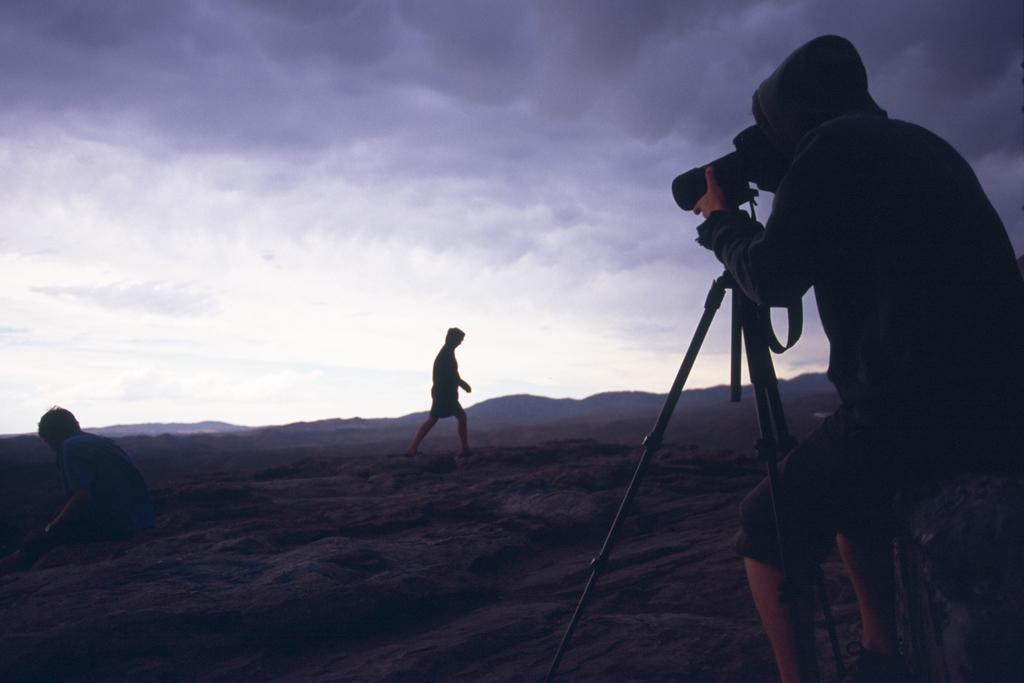How would you summarize this image in a sentence or two? In this image, we can see a person standing and we can see the camera stand and a camera, there is a person walking, at the top we can see the sky. 